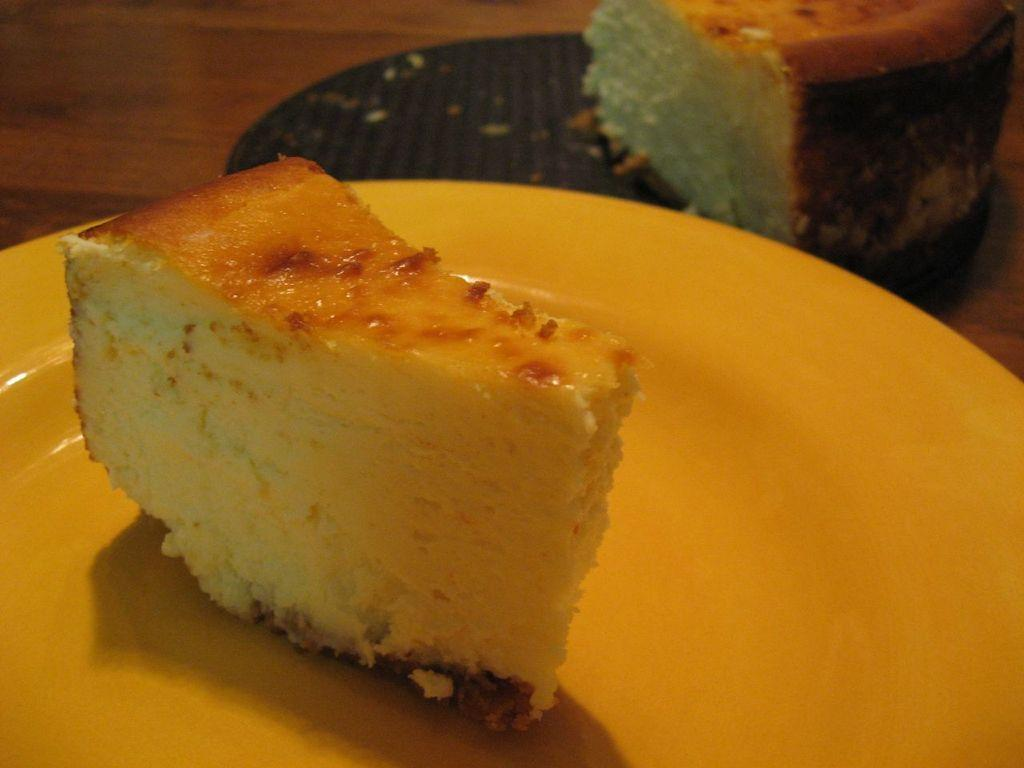What can be seen on the plate in the image? There is a food item on the plate in the image. Can you describe the plate itself? The facts provided do not give specific details about the plate, but we know it is present in the image. What type of knowledge is being shared on the plate in the image? There is no knowledge being shared on the plate in the image; it contains a food item. What type of patch is visible on the plate in the image? There is no patch present on the plate in the image. 